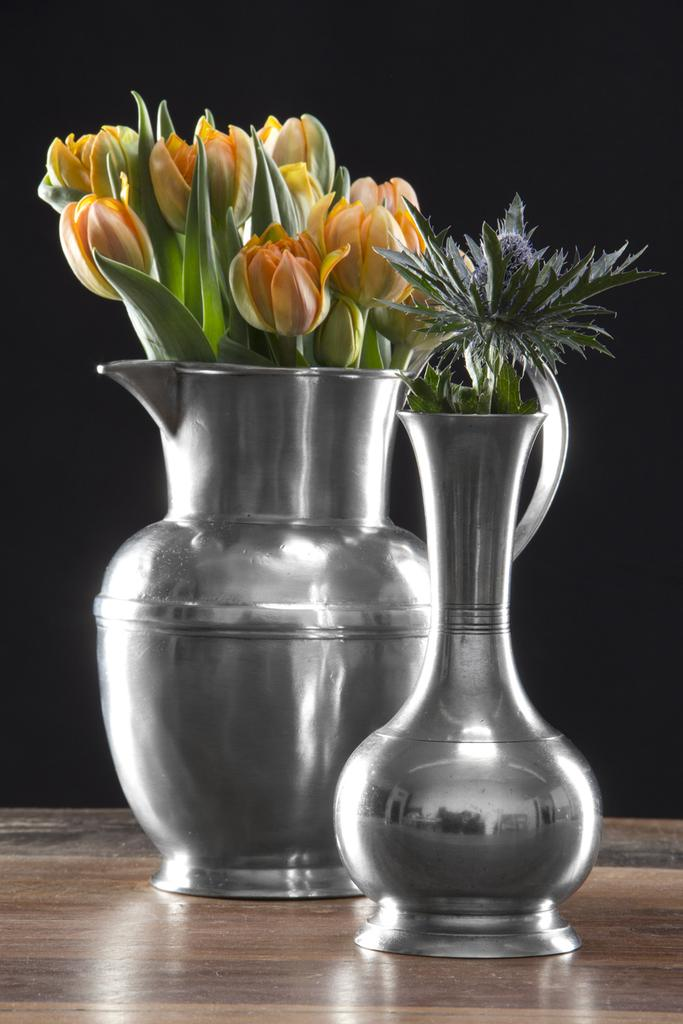What type of plants can be seen in the image? There are flower plants in the image. What are the flower plants placed in? The flower plants are in metal vases. Where are the metal vases located? The metal vases are present on a table. What part of the brain can be seen in the image? There is no brain present in the image; it features flower plants in metal vases on a table. What type of chain is used to hold the flower plants together? There is no chain present in the image; the flower plants are in separate metal vases. 